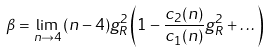<formula> <loc_0><loc_0><loc_500><loc_500>\beta = \lim _ { n \rightarrow 4 } \, ( n - 4 ) g ^ { 2 } _ { R } \left ( 1 - \frac { c _ { 2 } ( n ) } { c _ { 1 } ( n ) } g ^ { 2 } _ { R } + \dots \right )</formula> 